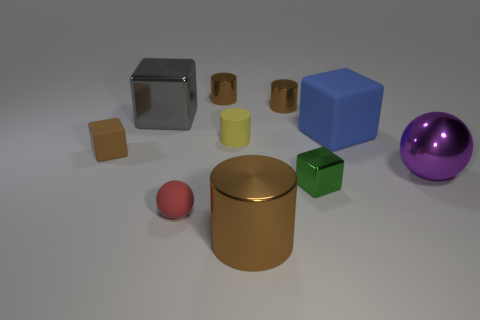What color is the large cylinder? brown 